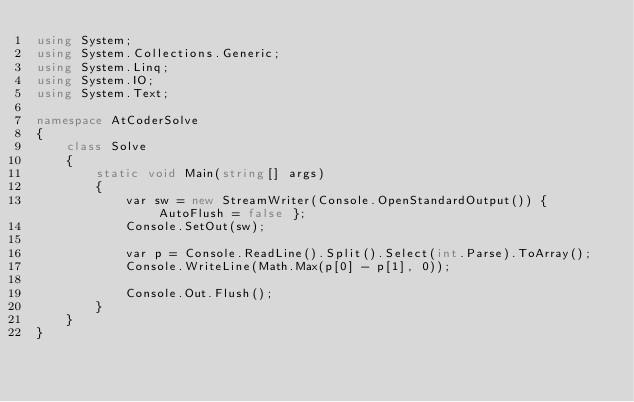<code> <loc_0><loc_0><loc_500><loc_500><_C#_>using System;
using System.Collections.Generic;
using System.Linq;
using System.IO;
using System.Text;

namespace AtCoderSolve
{
    class Solve
    {
        static void Main(string[] args)
        {
            var sw = new StreamWriter(Console.OpenStandardOutput()) { AutoFlush = false };
            Console.SetOut(sw);

            var p = Console.ReadLine().Split().Select(int.Parse).ToArray();
            Console.WriteLine(Math.Max(p[0] - p[1], 0));

            Console.Out.Flush();
        }
    }
}
</code> 